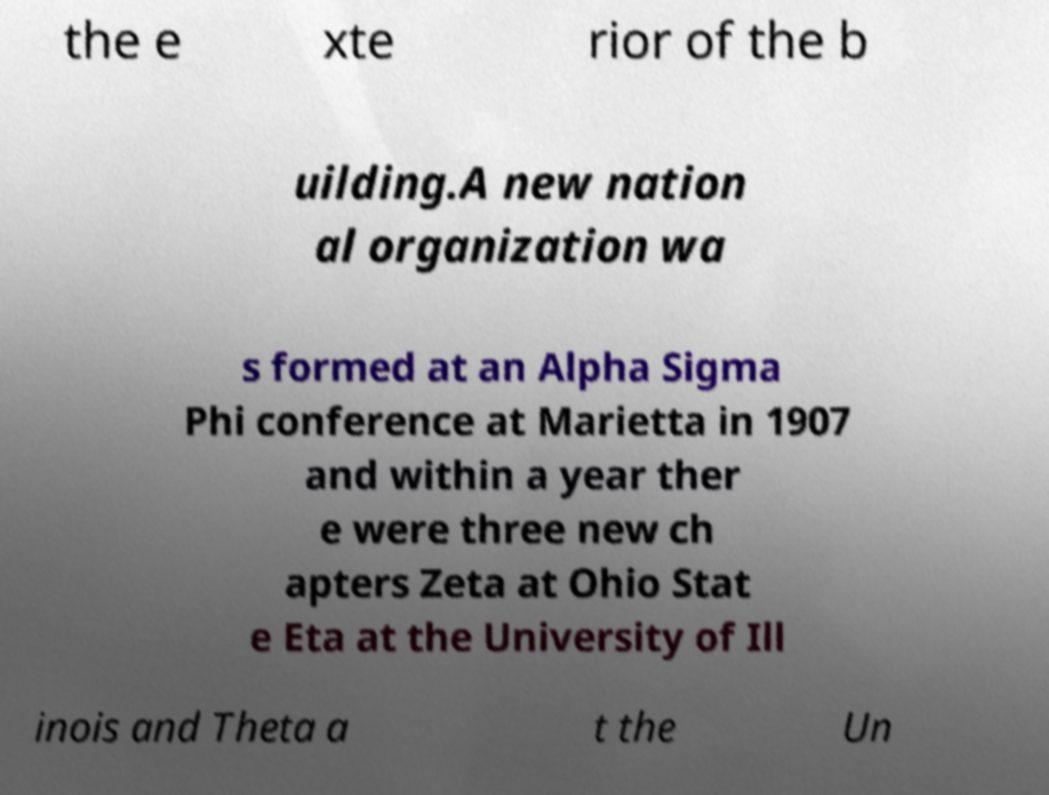For documentation purposes, I need the text within this image transcribed. Could you provide that? the e xte rior of the b uilding.A new nation al organization wa s formed at an Alpha Sigma Phi conference at Marietta in 1907 and within a year ther e were three new ch apters Zeta at Ohio Stat e Eta at the University of Ill inois and Theta a t the Un 